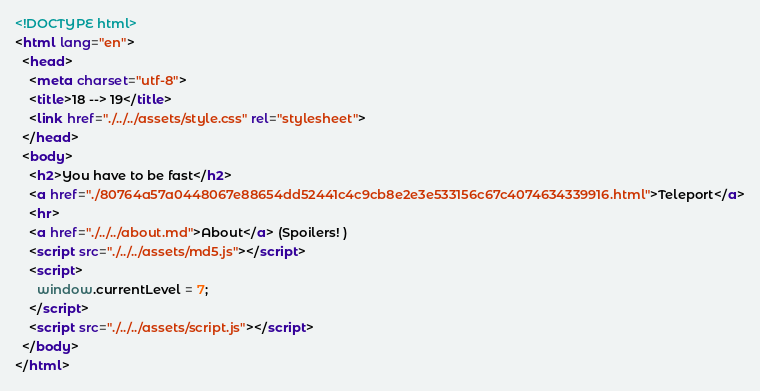Convert code to text. <code><loc_0><loc_0><loc_500><loc_500><_HTML_><!DOCTYPE html>
<html lang="en">
  <head>
    <meta charset="utf-8">
    <title>18 --> 19</title>
    <link href="./../../assets/style.css" rel="stylesheet">
  </head>
  <body>
    <h2>You have to be fast</h2>
    <a href="./80764a57a0448067e88654dd52441c4c9cb8e2e3e533156c67c4074634339916.html">Teleport</a>
    <hr>
    <a href="./../../about.md">About</a> (Spoilers! )
    <script src="./../../assets/md5.js"></script>
    <script>
      window.currentLevel = 7;
    </script>
    <script src="./../../assets/script.js"></script>
  </body>
</html></code> 